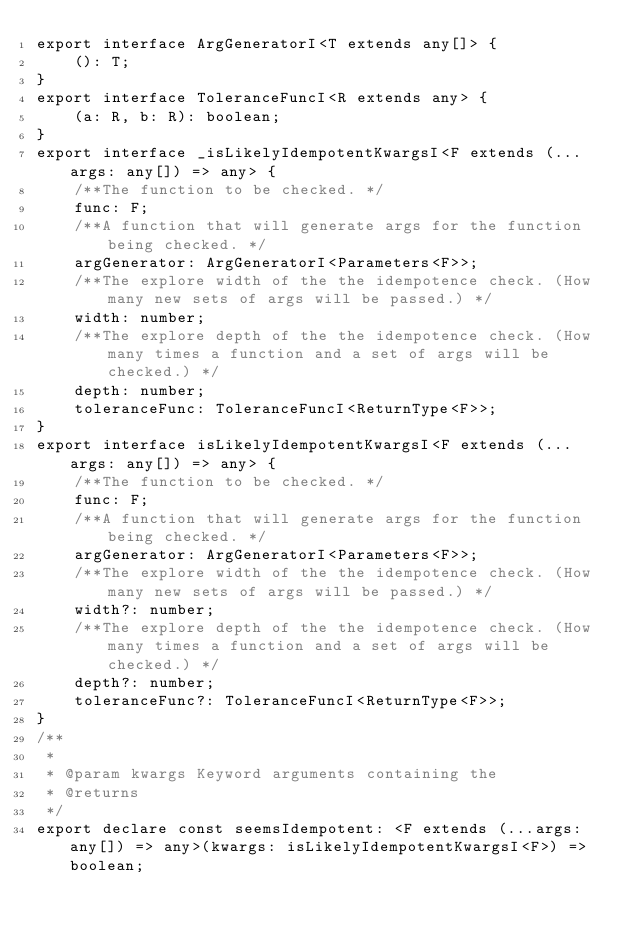Convert code to text. <code><loc_0><loc_0><loc_500><loc_500><_TypeScript_>export interface ArgGeneratorI<T extends any[]> {
    (): T;
}
export interface ToleranceFuncI<R extends any> {
    (a: R, b: R): boolean;
}
export interface _isLikelyIdempotentKwargsI<F extends (...args: any[]) => any> {
    /**The function to be checked. */
    func: F;
    /**A function that will generate args for the function being checked. */
    argGenerator: ArgGeneratorI<Parameters<F>>;
    /**The explore width of the the idempotence check. (How many new sets of args will be passed.) */
    width: number;
    /**The explore depth of the the idempotence check. (How many times a function and a set of args will be checked.) */
    depth: number;
    toleranceFunc: ToleranceFuncI<ReturnType<F>>;
}
export interface isLikelyIdempotentKwargsI<F extends (...args: any[]) => any> {
    /**The function to be checked. */
    func: F;
    /**A function that will generate args for the function being checked. */
    argGenerator: ArgGeneratorI<Parameters<F>>;
    /**The explore width of the the idempotence check. (How many new sets of args will be passed.) */
    width?: number;
    /**The explore depth of the the idempotence check. (How many times a function and a set of args will be checked.) */
    depth?: number;
    toleranceFunc?: ToleranceFuncI<ReturnType<F>>;
}
/**
 *
 * @param kwargs Keyword arguments containing the
 * @returns
 */
export declare const seemsIdempotent: <F extends (...args: any[]) => any>(kwargs: isLikelyIdempotentKwargsI<F>) => boolean;
</code> 